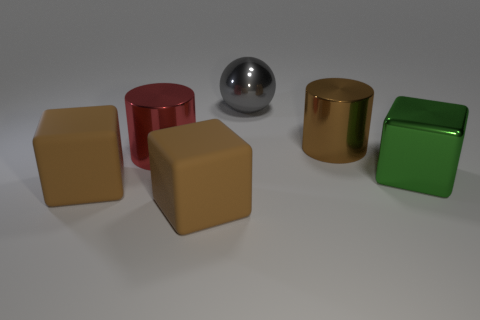Is the number of big red metal objects that are to the left of the brown shiny object greater than the number of big metal spheres to the right of the green cube?
Your answer should be very brief. Yes. There is a large object that is both in front of the brown metallic object and behind the big green block; what material is it?
Ensure brevity in your answer.  Metal. Is the shape of the red shiny object the same as the green metal thing?
Keep it short and to the point. No. How many big cubes are on the left side of the large red shiny cylinder?
Your response must be concise. 1. Do the thing behind the brown cylinder and the big brown shiny object have the same size?
Provide a short and direct response. Yes. What is the color of the other metal thing that is the same shape as the large red metallic thing?
Your response must be concise. Brown. Are there any other things that are the same shape as the gray shiny thing?
Give a very brief answer. No. What shape is the large object that is behind the brown metallic cylinder?
Provide a short and direct response. Sphere. How many other green metal things are the same shape as the big green metallic object?
Give a very brief answer. 0. There is a metallic cylinder right of the big gray ball; does it have the same color as the rubber thing to the right of the red metal object?
Keep it short and to the point. Yes. 